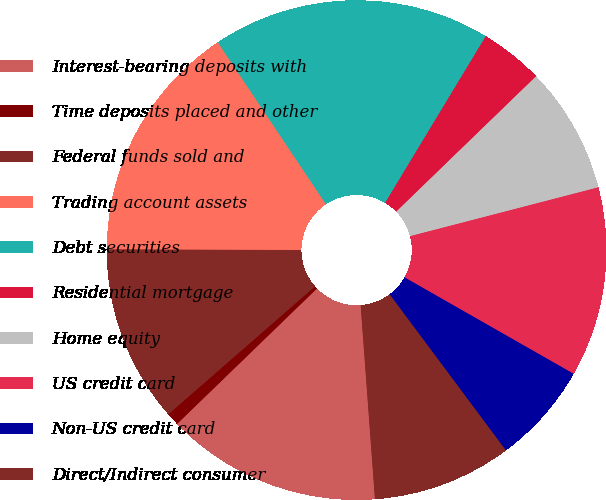<chart> <loc_0><loc_0><loc_500><loc_500><pie_chart><fcel>Interest-bearing deposits with<fcel>Time deposits placed and other<fcel>Federal funds sold and<fcel>Trading account assets<fcel>Debt securities<fcel>Residential mortgage<fcel>Home equity<fcel>US credit card<fcel>Non-US credit card<fcel>Direct/Indirect consumer<nl><fcel>13.93%<fcel>0.83%<fcel>11.47%<fcel>15.57%<fcel>18.02%<fcel>4.11%<fcel>8.2%<fcel>12.29%<fcel>6.56%<fcel>9.02%<nl></chart> 